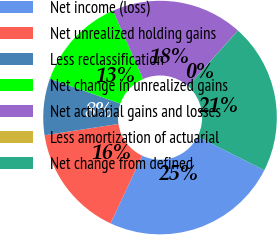Convert chart. <chart><loc_0><loc_0><loc_500><loc_500><pie_chart><fcel>Net income (loss)<fcel>Net unrealized holding gains<fcel>Less reclassification<fcel>Net change in unrealized gains<fcel>Net actuarial gains and losses<fcel>Less amortization of actuarial<fcel>Net change from defined<nl><fcel>24.52%<fcel>15.61%<fcel>7.81%<fcel>13.01%<fcel>18.21%<fcel>0.01%<fcel>20.81%<nl></chart> 